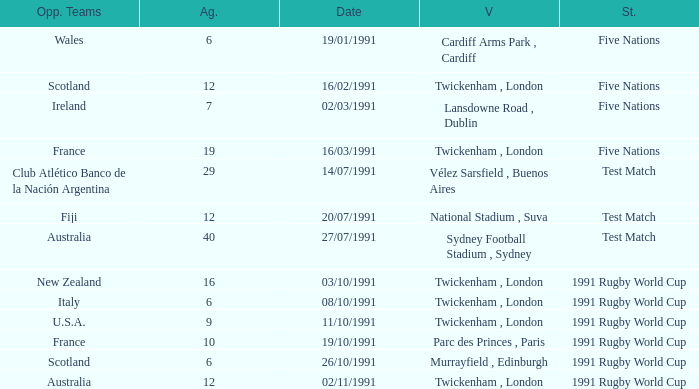What is Venue, when Status is "Test Match", and when Against is "12"? National Stadium , Suva. 